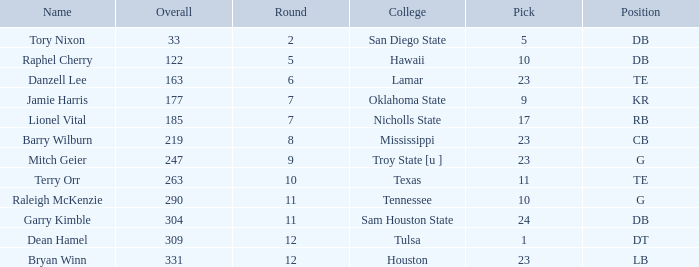Which Round is the highest one that has a Pick smaller than 10, and a Name of tory nixon? 2.0. 